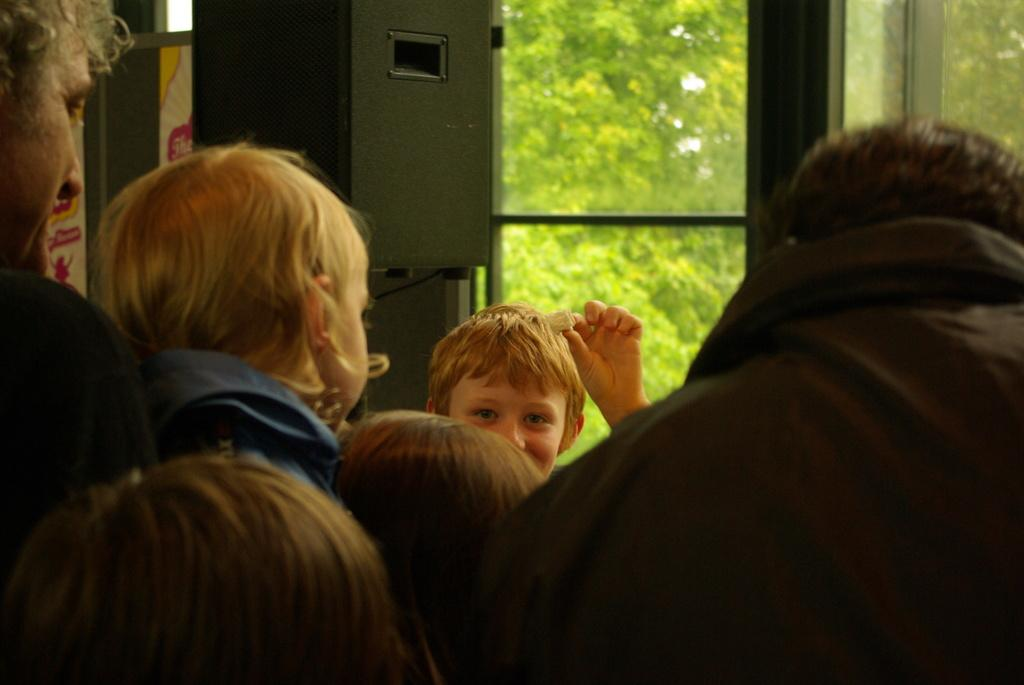What is the main subject of the image? The main subject of the image is a kid. What is the kid holding in his hands? The kid is holding an object in his hands. Can you describe any other objects in the image? Yes, there is a speaker in the image. What can be seen in the background of the image? There are trees behind the kid. Are there any people in the image? Yes, there are people standing in front of the kid. Can you tell me how many ladybugs are on the speaker in the image? There are no ladybugs present on the speaker in the image. What type of badge is the kid wearing in the image? The kid is not wearing a badge in the image. 